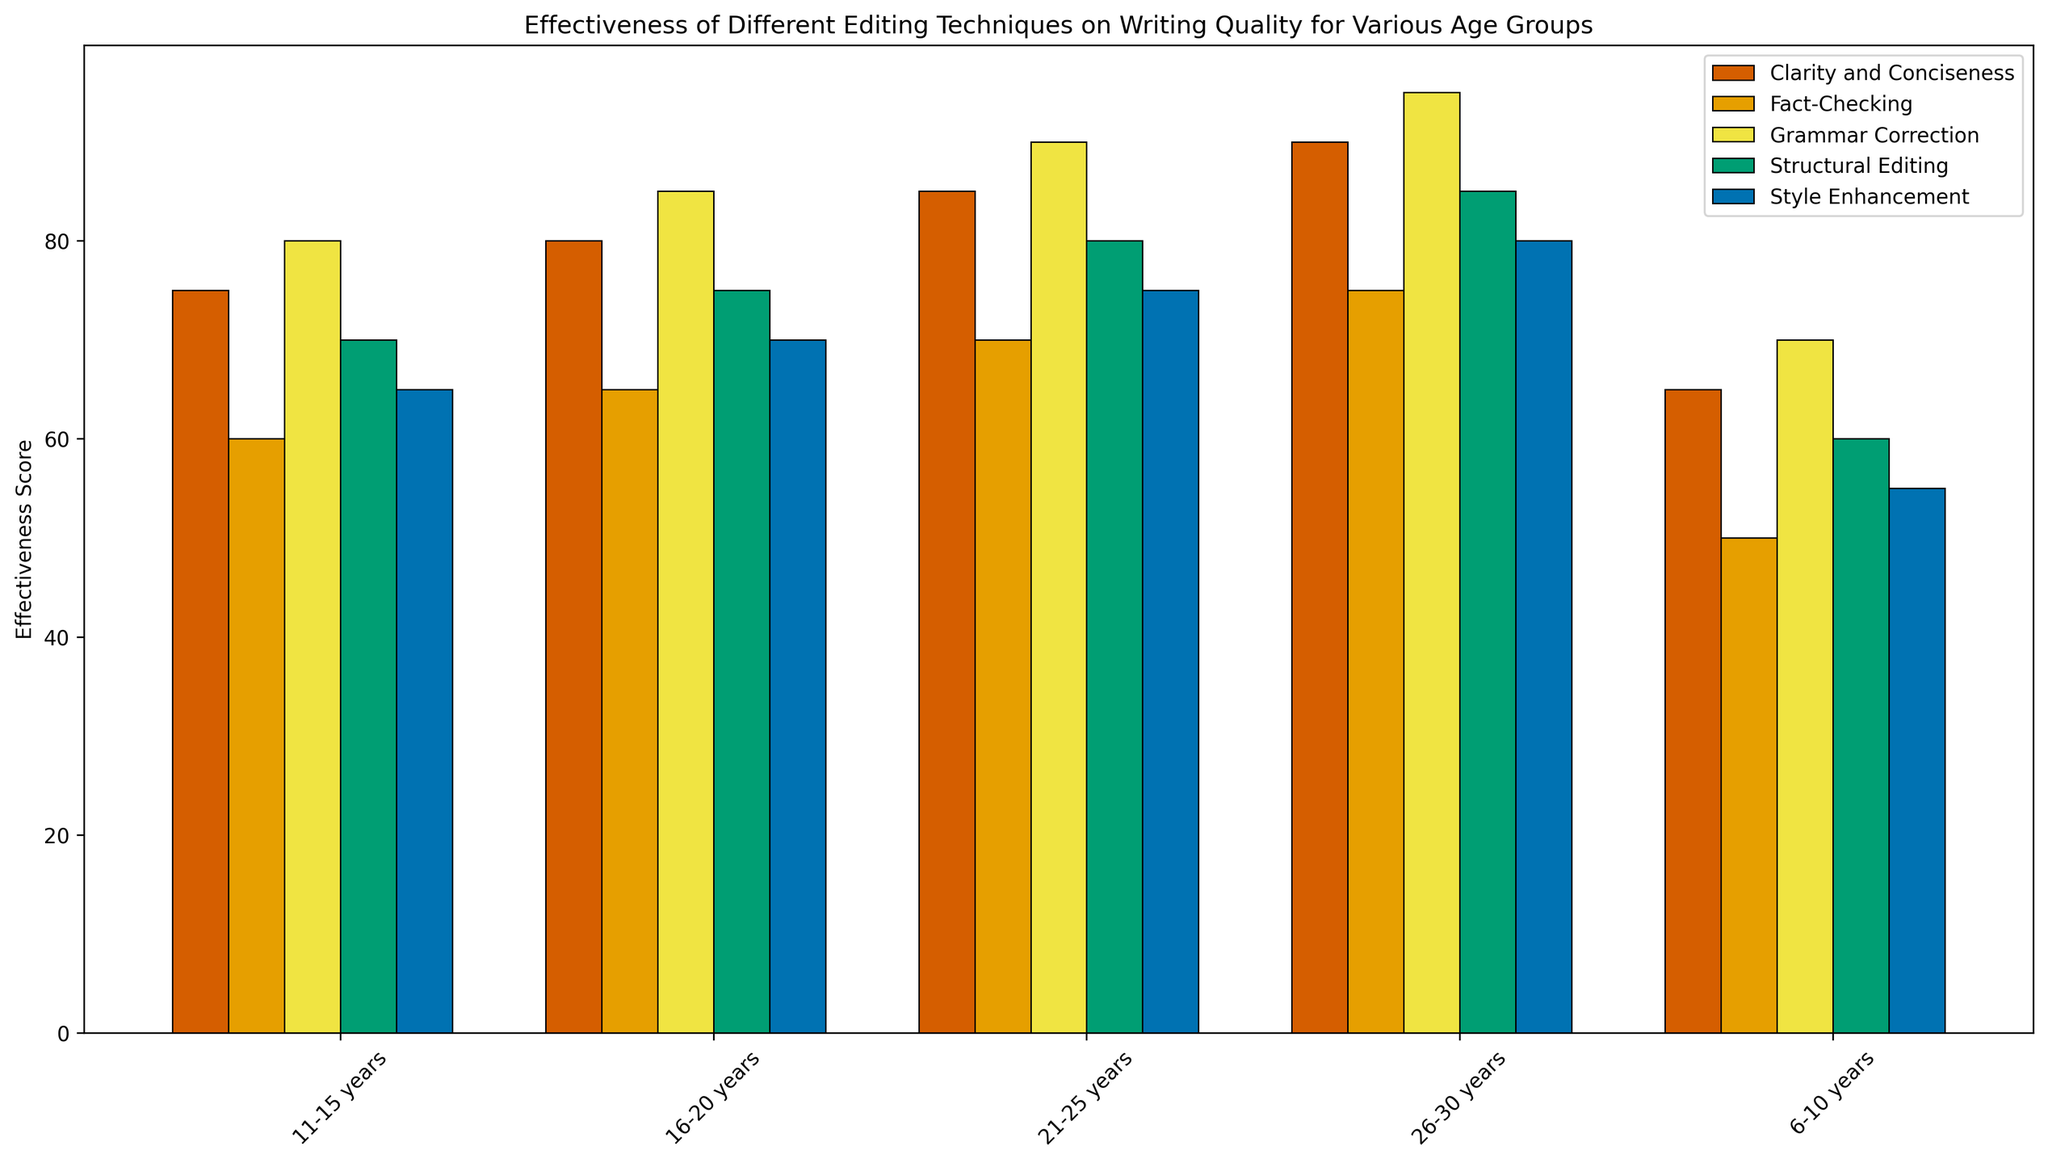What is the most effective editing technique for the 26-30 years age group? In the figure, identify the bar with the highest value for the 26-30 years age group. This bar represents the "Grammar Correction" technique, indicating its highest effectiveness score.
Answer: Grammar Correction Which age group finds "Clarity and Conciseness" most effective? Compare the heights of the bars labeled "Clarity and Conciseness" across all age groups. The tallest bar can be seen in the 26-30 years age group.
Answer: 26-30 years For the age group 11-15 years, which technique is more effective: "Structural Editing" or "Style Enhancement"? Compare the heights of the bars for "Structural Editing" and "Style Enhancement" within the 11-15 years age group. "Structural Editing" has a taller bar, indicating it is more effective.
Answer: Structural Editing What is the average effectiveness score of "Fact-Checking" across all age groups? Sum the "Fact-Checking" scores across all age groups (50 + 60 + 65 + 70 + 75 = 320) and divide by the number of age groups (5). The average is 320/5 = 64.
Answer: 64 Which technique shows a consistent increase in effectiveness score from the youngest to the oldest age group? Examine the trend of each technique's effectiveness score across age groups. "Grammar Correction" shows a consistent increase from 6-10 to 26-30 years (70, 80, 85, 90, 95).
Answer: Grammar Correction What is the range of the effectiveness score for "Style Enhancement" across all age groups? Identify the minimum and maximum effectiveness scores of "Style Enhancement" (55 and 80 respectively). Subtract the minimum from the maximum (80 - 55 = 25).
Answer: 25 Comparing "Fact-Checking" and "Grammar Correction" for the 21-25 years age group, which has a higher score and by how much? Check the effectiveness scores for "Fact-Checking" (70) and "Grammar Correction" (90) in the 21-25 years age group. Subtract the "Fact-Checking" score from the "Grammar Correction" score (90 - 70 = 20).
Answer: Grammar Correction by 20 6-10 years: 65 - 60
Answer: = 5 11-15 years: 75 - 70
Answer: = 5 16-20 years: 80 - 75
Answer: = 5 21-25 years: 85 - 80
Answer: = 5 26-30 years: 90 - 85
Answer: = 5 What colors represent "Clarity and Conciseness" and "Style Enhancement"? Refer to the legend to find the colors corresponding to each technique. "Clarity and Conciseness" is represented in a yellow-like color and "Style Enhancement" in green-like color.
Answer: Yellow for Clarity and Conciseness, Green for Style Enhancement 